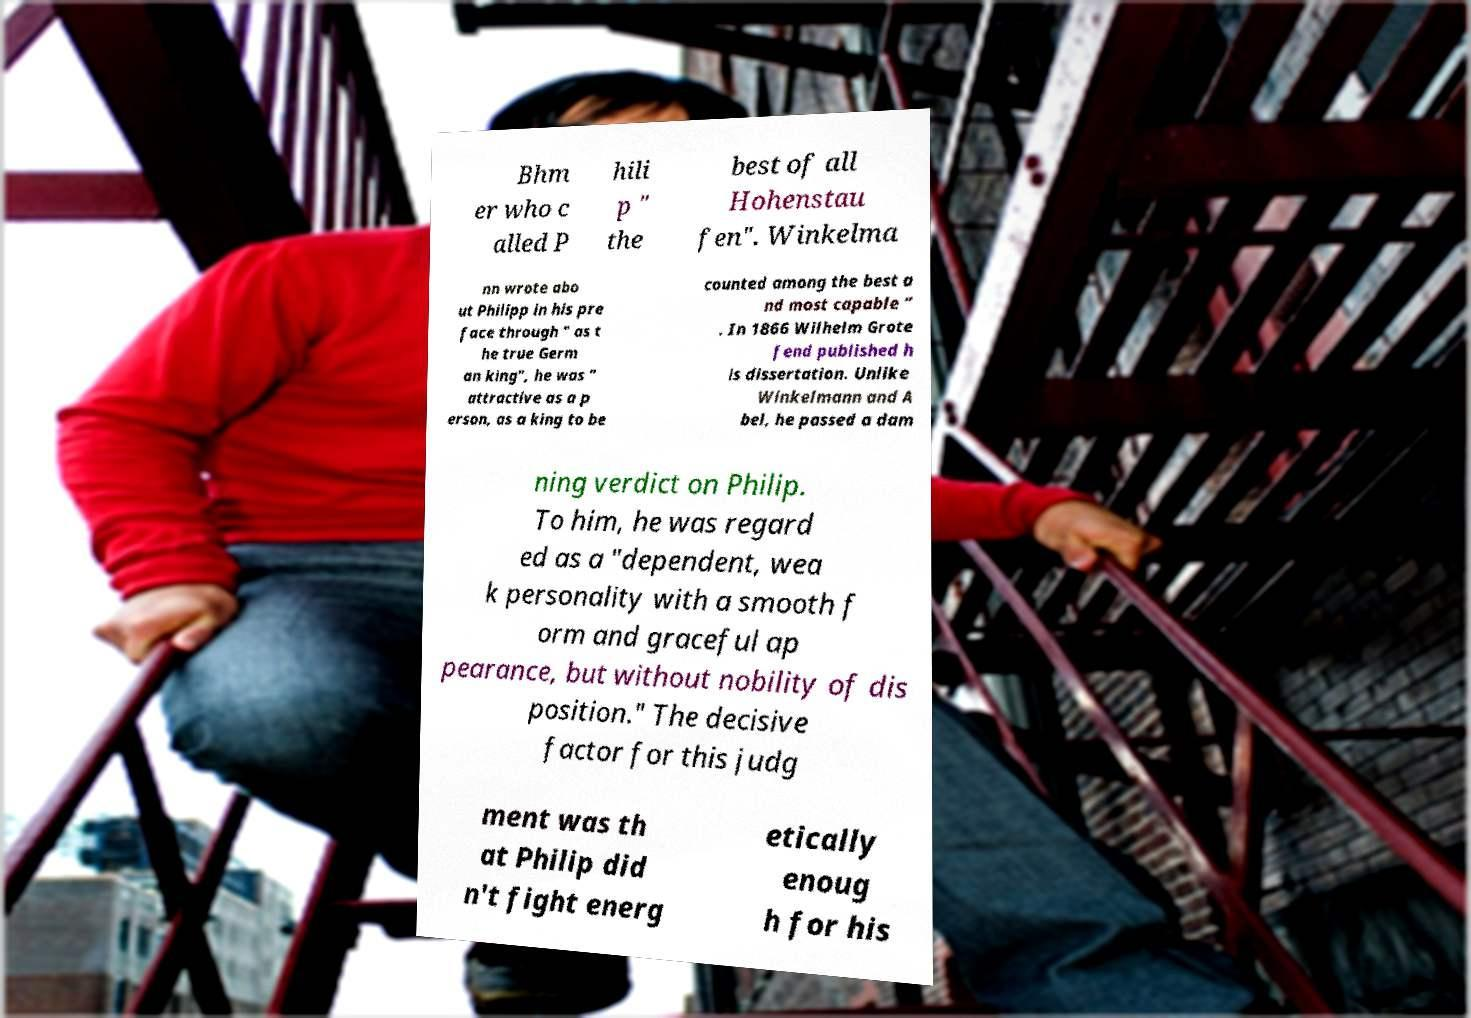Could you extract and type out the text from this image? Bhm er who c alled P hili p " the best of all Hohenstau fen". Winkelma nn wrote abo ut Philipp in his pre face through " as t he true Germ an king", he was " attractive as a p erson, as a king to be counted among the best a nd most capable ” . In 1866 Wilhelm Grote fend published h is dissertation. Unlike Winkelmann and A bel, he passed a dam ning verdict on Philip. To him, he was regard ed as a "dependent, wea k personality with a smooth f orm and graceful ap pearance, but without nobility of dis position." The decisive factor for this judg ment was th at Philip did n't fight energ etically enoug h for his 